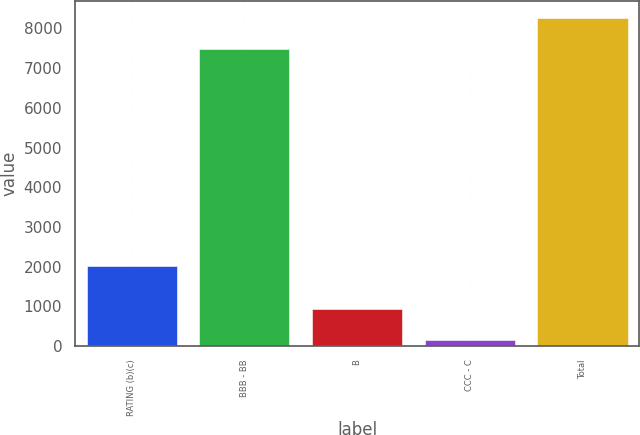<chart> <loc_0><loc_0><loc_500><loc_500><bar_chart><fcel>RATING (b)(c)<fcel>BBB - BB<fcel>B<fcel>CCC - C<fcel>Total<nl><fcel>2015<fcel>7492<fcel>937.2<fcel>157<fcel>8272.2<nl></chart> 